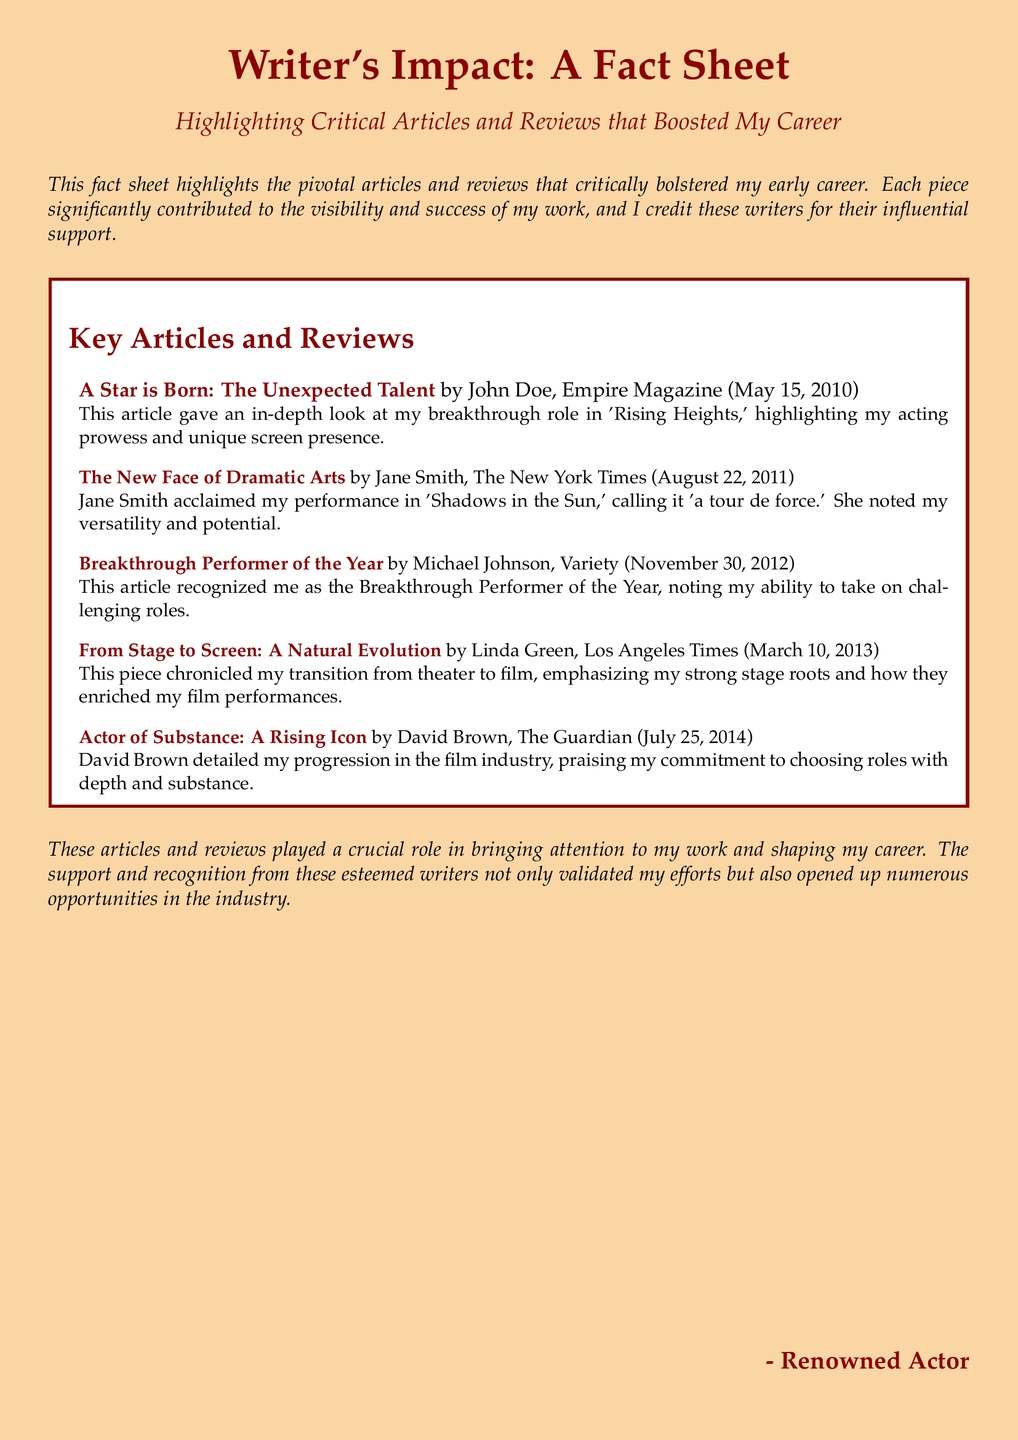What is the title of the fact sheet? The title of the fact sheet is prominently displayed at the top of the document, stating "Writer's Impact: A Fact Sheet."
Answer: Writer's Impact: A Fact Sheet Who authored the article "A Star is Born: The Unexpected Talent"? The author's name is mentioned alongside the article title in the list of key articles and reviews.
Answer: John Doe What publication featured "The New Face of Dramatic Arts"? The publication is listed directly with the article information in the document.
Answer: The New York Times When was "Breakthrough Performer of the Year" published? The publication date is explicitly provided in parentheses next to the article title.
Answer: November 30, 2012 Which article emphasized the transition from theater to film? The content of the document indicates this article in the list provided.
Answer: From Stage to Screen: A Natural Evolution How did David Brown describe the actor's role choices? The specific phrase describing the actor's choices is available in the excerpt from the article.
Answer: Depth and substance How many articles are listed in the fact sheet? The total number of articles can be counted from the list presented in the document.
Answer: Five What date was "Actor of Substance: A Rising Icon" published? The date is attached to the article title in the fact sheet.
Answer: July 25, 2014 Which writer praised the performance in 'Shadows in the Sun'? The name of the writer is provided in connection with the article about the performance.
Answer: Jane Smith 